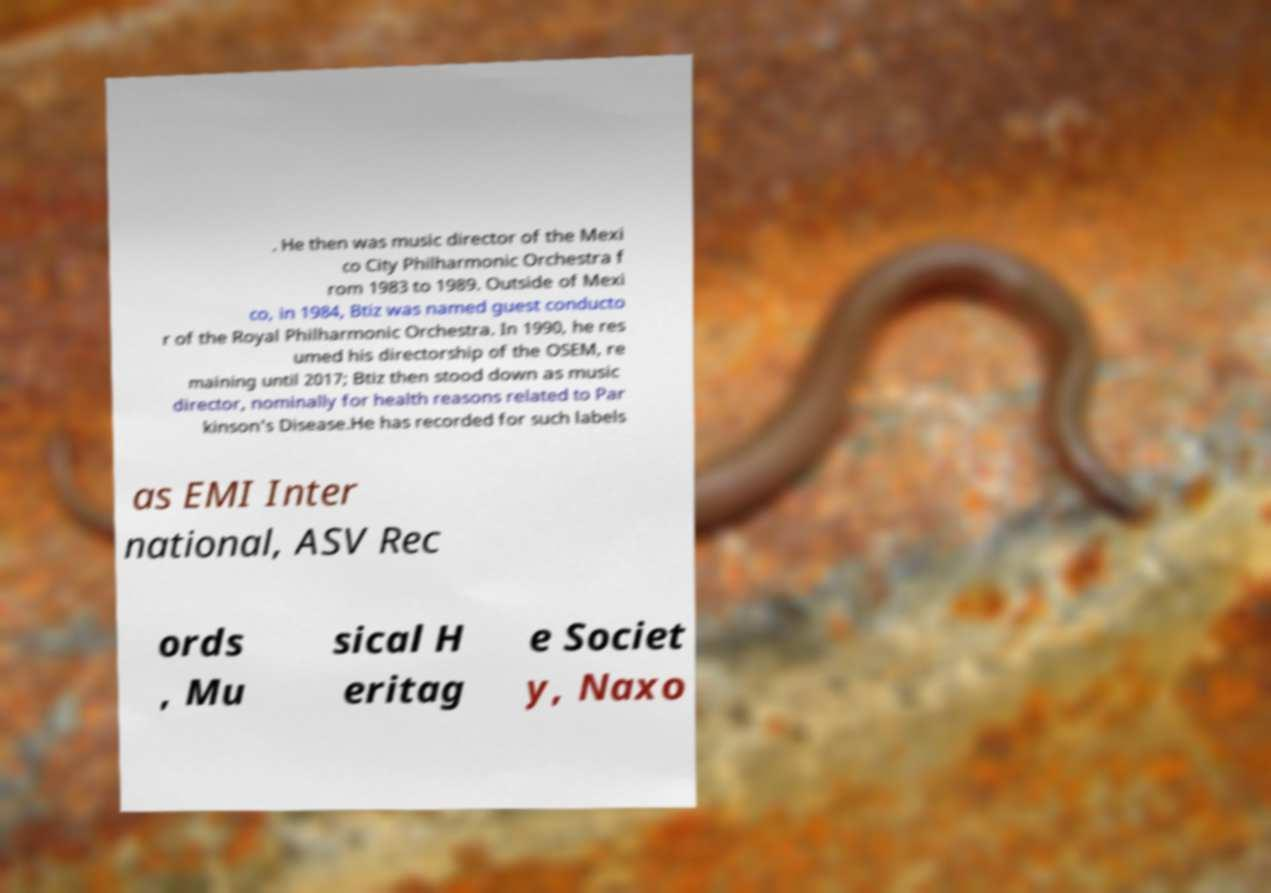Please read and relay the text visible in this image. What does it say? . He then was music director of the Mexi co City Philharmonic Orchestra f rom 1983 to 1989. Outside of Mexi co, in 1984, Btiz was named guest conducto r of the Royal Philharmonic Orchestra. In 1990, he res umed his directorship of the OSEM, re maining until 2017; Btiz then stood down as music director, nominally for health reasons related to Par kinson's Disease.He has recorded for such labels as EMI Inter national, ASV Rec ords , Mu sical H eritag e Societ y, Naxo 